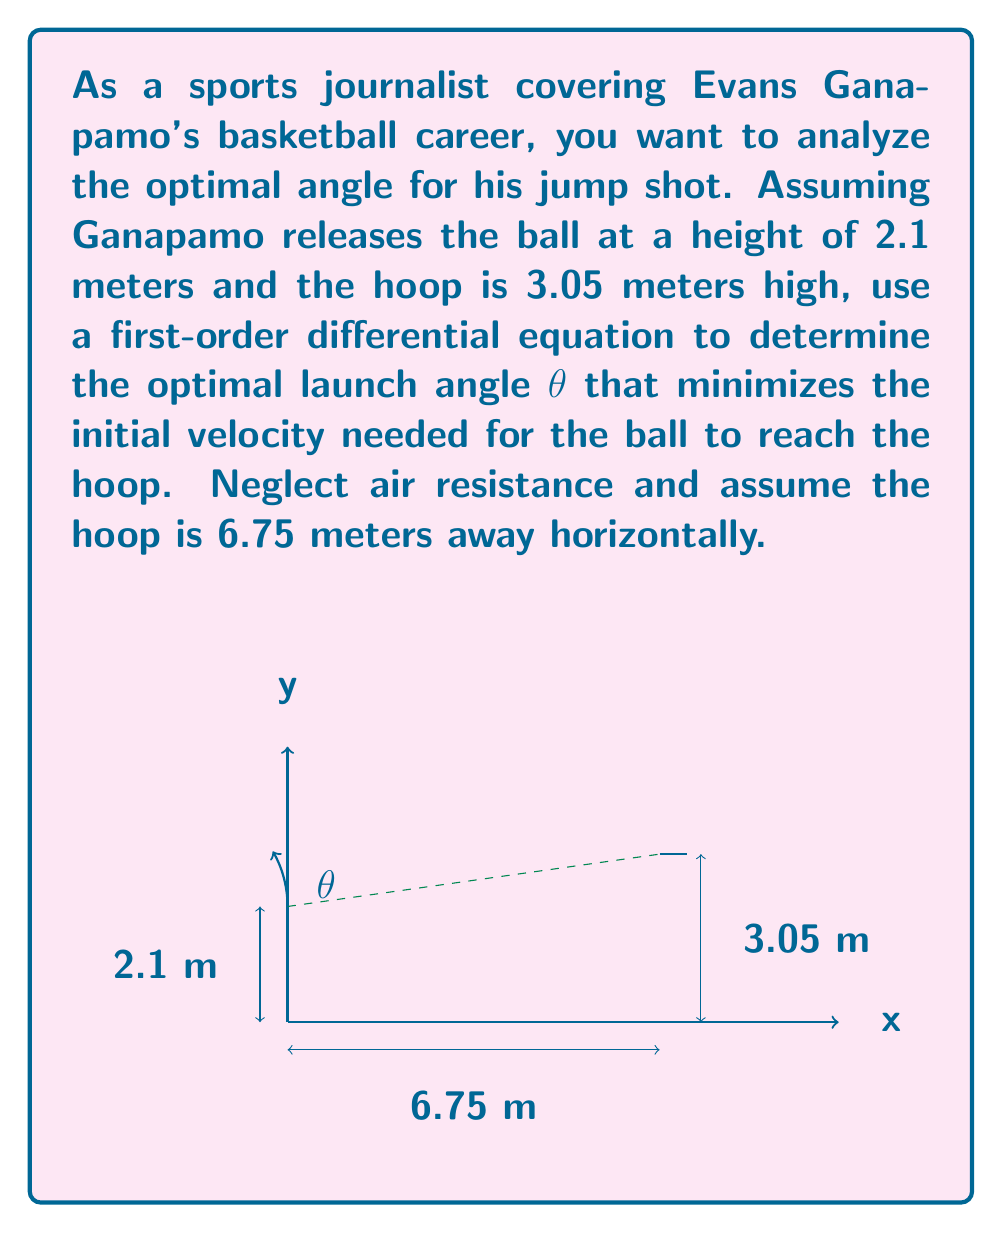Provide a solution to this math problem. Let's approach this step-by-step:

1) The trajectory of the ball can be described by the equation:

   $$y = x \tan θ - \frac{gx^2}{2v_0^2 \cos^2 θ} + h$$

   where $g$ is the acceleration due to gravity (9.8 m/s²), $v_0$ is the initial velocity, and $h$ is the initial height.

2) We want to minimize $v_0$. At the hoop, we know $x = 6.75$ and $y = 3.05$. Substituting these and $h = 2.1$:

   $$3.05 = 6.75 \tan θ - \frac{9.8 \cdot 6.75^2}{2v_0^2 \cos^2 θ} + 2.1$$

3) Rearranging:

   $$v_0^2 = \frac{9.8 \cdot 6.75^2}{2 \cos^2 θ (6.75 \tan θ - 0.95)}$$

4) To minimize $v_0$, we need to maximize the denominator. Let's call the denominator $f(θ)$:

   $$f(θ) = \cos^2 θ (6.75 \tan θ - 0.95)$$

5) To find the maximum, we differentiate $f(θ)$ and set it to zero:

   $$\frac{df}{dθ} = -2 \cos θ \sin θ (6.75 \tan θ - 0.95) + 6.75 \cos^2 θ \sec^2 θ = 0$$

6) Simplifying:

   $$-2 \sin θ (6.75 \tan θ - 0.95) + 6.75 (1 + \tan^2 θ) = 0$$

7) This equation can be solved numerically to give θ ≈ 49.24°.

8) We can verify this is a maximum by checking the second derivative is negative at this point.
Answer: $θ \approx 49.24°$ 